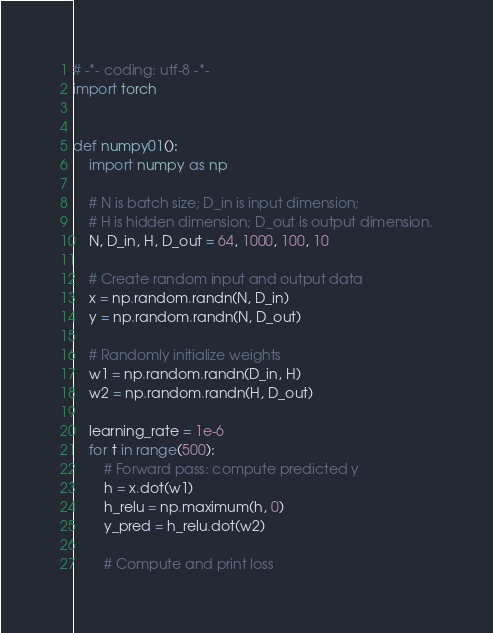<code> <loc_0><loc_0><loc_500><loc_500><_Python_># -*- coding: utf-8 -*-
import torch


def numpy01():
    import numpy as np

    # N is batch size; D_in is input dimension;
    # H is hidden dimension; D_out is output dimension.
    N, D_in, H, D_out = 64, 1000, 100, 10

    # Create random input and output data
    x = np.random.randn(N, D_in)
    y = np.random.randn(N, D_out)

    # Randomly initialize weights
    w1 = np.random.randn(D_in, H)
    w2 = np.random.randn(H, D_out)

    learning_rate = 1e-6
    for t in range(500):
        # Forward pass: compute predicted y
        h = x.dot(w1)
        h_relu = np.maximum(h, 0)
        y_pred = h_relu.dot(w2)

        # Compute and print loss</code> 